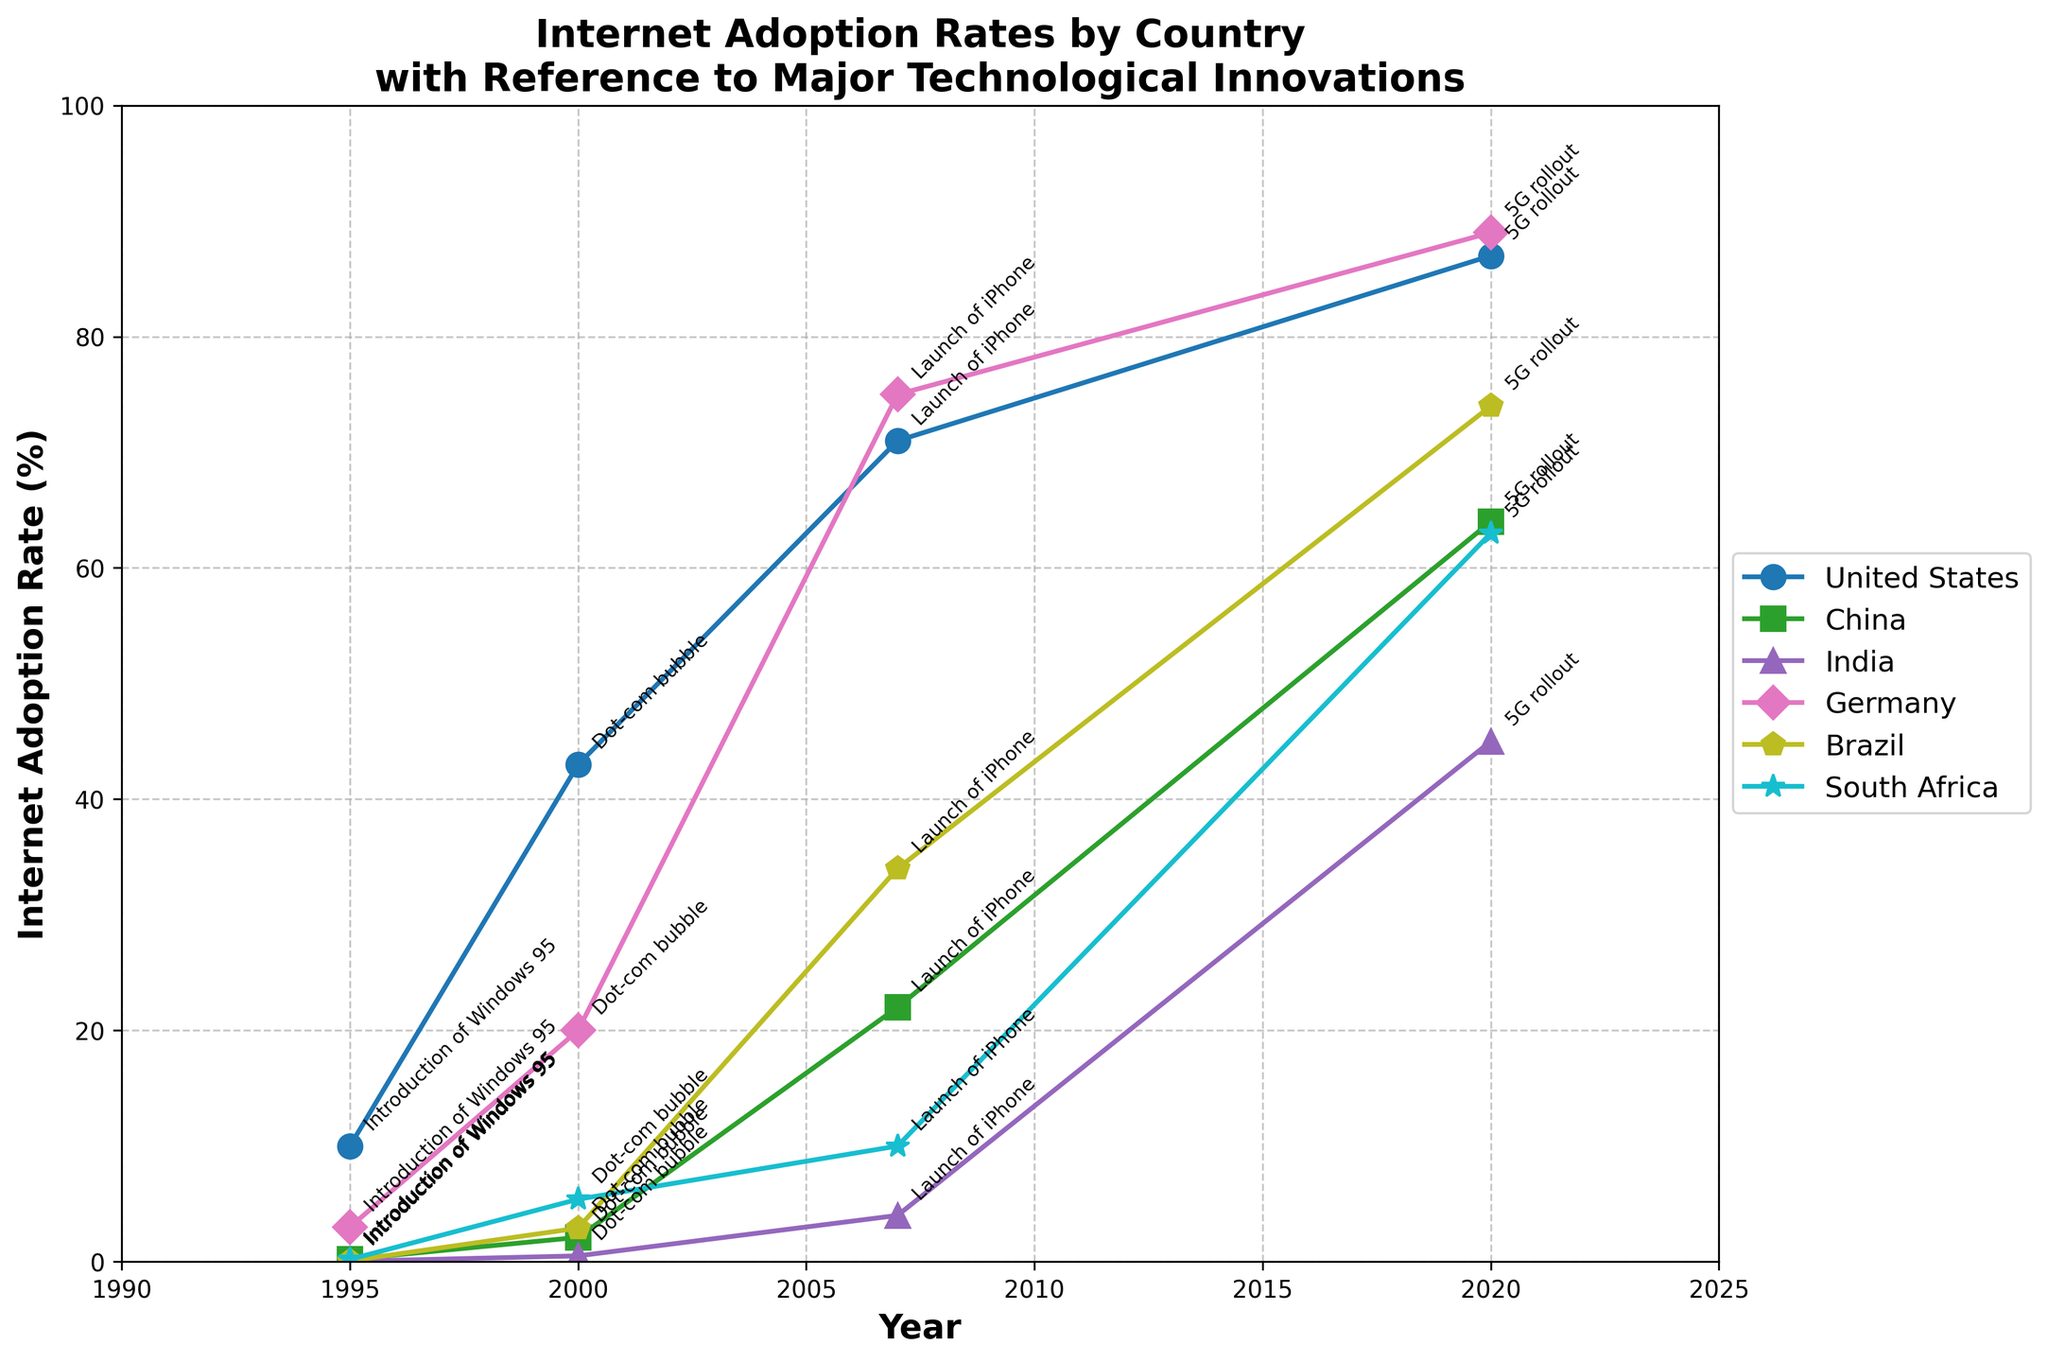What is the title of the plot? The title of the plot is "Internet Adoption Rates by Country with Reference to Major Technological Innovations". This is clearly seen at the top of the figure.
Answer: Internet Adoption Rates by Country with Reference to Major Technological Innovations Which country had the highest Internet adoption rate in 2020? By looking at the data points on the graph for the year 2020, Germany had the highest Internet adoption rate, marked at 89%.
Answer: Germany Between 1995 to 2020, which country showed the largest increase in Internet adoption rate? To determine the largest increase, we need to subtract the Internet adoption rate in 1995 from the rate in 2020 for each country. The increases are: United States (77%), China (63.8%), India (44.97%), Germany (86%), Brazil (73.93%), South Africa (62.8%). Germany shows the largest increase of 86%.
Answer: Germany At which major technological innovation did China see a significant jump in Internet adoption rates? For China, the significant jump can be observed around the "Launch of iPhone" in 2007, where the Internet adoption rate rose significantly from 2.1% in 2000 to 22% in 2007.
Answer: Launch of iPhone Which two countries had almost similar Internet adoption rates in 2020? By examining the final data points for each country in 2020, Brazil and South Africa had similar internet adoption rates of 74% and 63% respectively. Hence, among the given countries, Brazil (74%) and South Africa (63%) are the closest in value.
Answer: Brazil and South Africa What trend can be observed in India's Internet adoption rate from 1995 to 2020? India's Internet adoption rate shows a consistent upward trend. Starting from 0.03% in 1995, it increased to 0.5% in 2000, 4% in 2007, and finally reached 45% in 2020. This confirms a steady growth over the years.
Answer: Consistent upward trend What was the Internet adoption rate in Germany at the time of the introduction of Windows 95 and the launch of the iPhone? The adoption rates in Germany during these times were 3% at the introduction of Windows 95 in 1995, and 75% at the launch of the iPhone in 2007, according to the data points on the graph.
Answer: 3% and 75% Did Brazil or South Africa have a higher Internet adoption rate in 2000? From the data points corresponding to the year 2000, Brazil had an internet adoption rate of 2.9%, while South Africa had a rate of 5.4%. Thus, South Africa had a higher rate.
Answer: South Africa How does the growth in Internet adoption rate in the United States from 1995 to 2020 compare to that in China? In the United States, the Internet adoption rate increased from 10% in 1995 to 87% in 2020, an increase of 77%. In China, it increased from 0.2% in 1995 to 64% in 2020, an increase of 63.8%. Thus, the United States saw a slightly higher growth compared to China.
Answer: The United States saw higher growth 